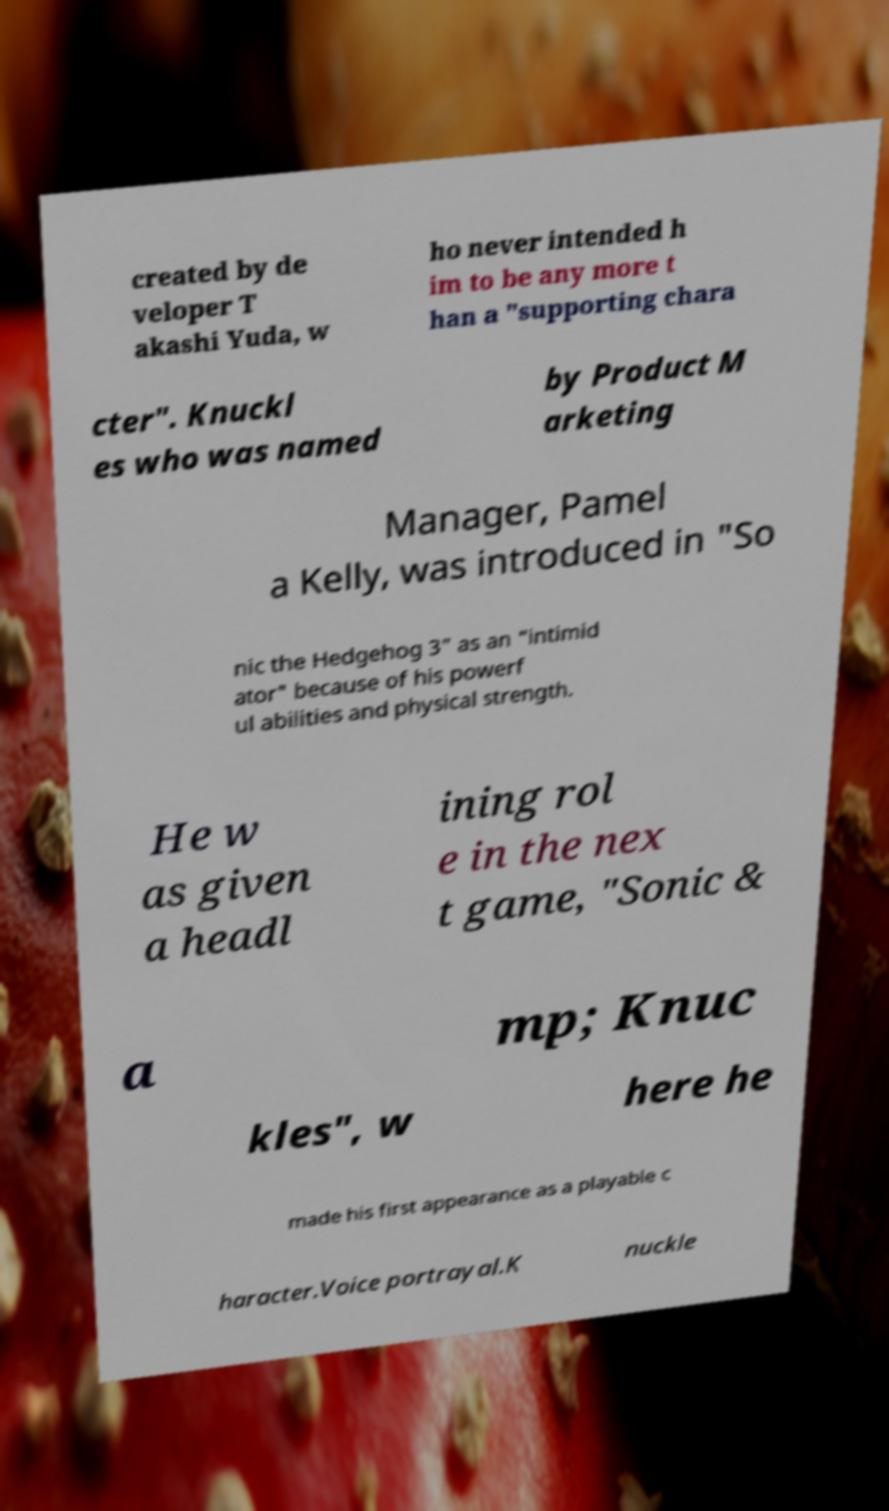There's text embedded in this image that I need extracted. Can you transcribe it verbatim? created by de veloper T akashi Yuda, w ho never intended h im to be any more t han a "supporting chara cter". Knuckl es who was named by Product M arketing Manager, Pamel a Kelly, was introduced in "So nic the Hedgehog 3" as an "intimid ator" because of his powerf ul abilities and physical strength. He w as given a headl ining rol e in the nex t game, "Sonic & a mp; Knuc kles", w here he made his first appearance as a playable c haracter.Voice portrayal.K nuckle 